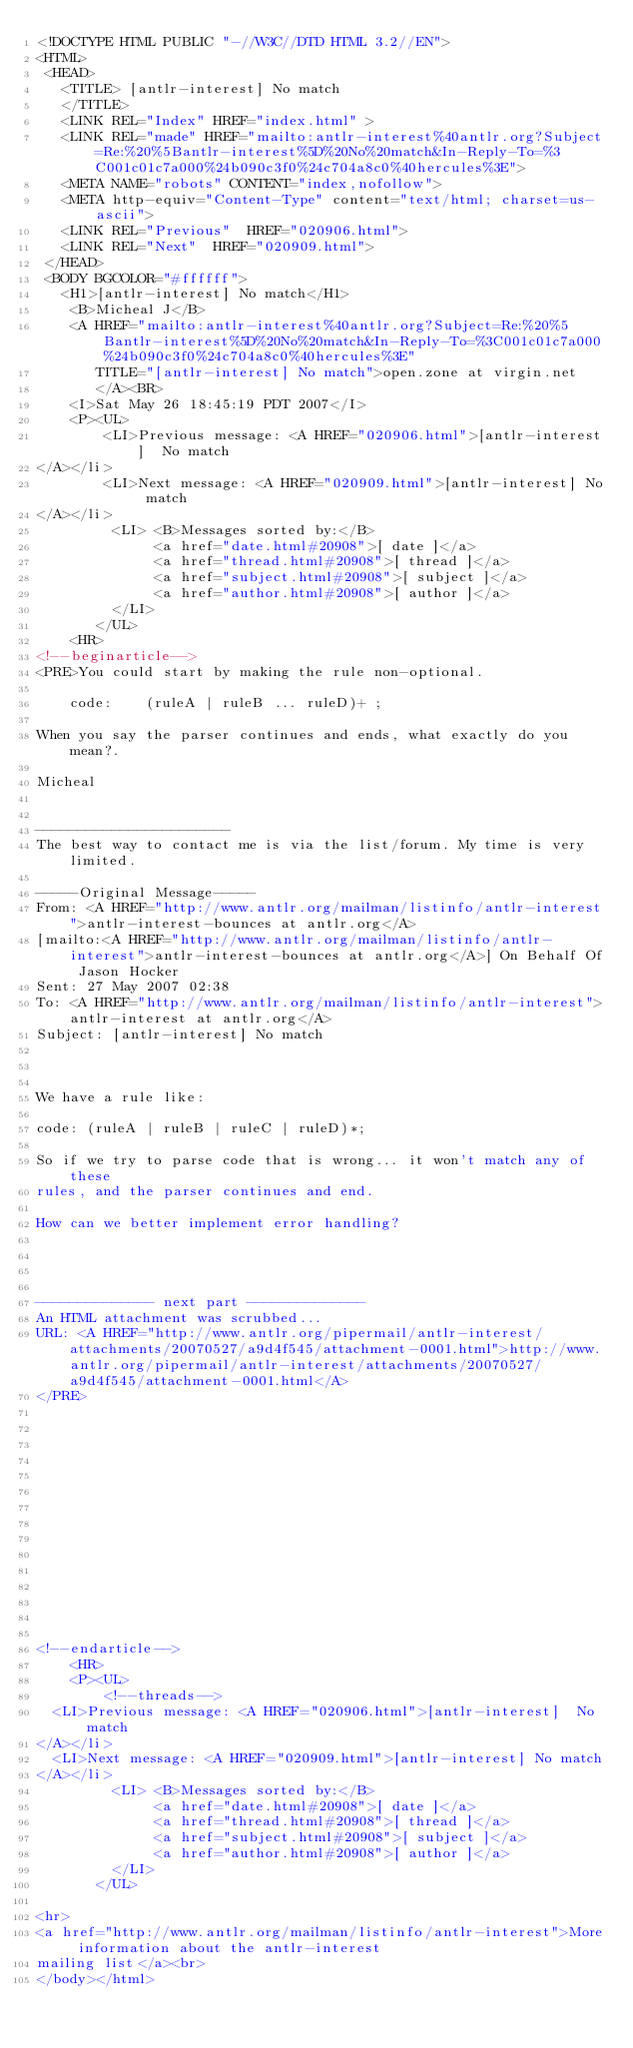Convert code to text. <code><loc_0><loc_0><loc_500><loc_500><_HTML_><!DOCTYPE HTML PUBLIC "-//W3C//DTD HTML 3.2//EN">
<HTML>
 <HEAD>
   <TITLE> [antlr-interest] No match
   </TITLE>
   <LINK REL="Index" HREF="index.html" >
   <LINK REL="made" HREF="mailto:antlr-interest%40antlr.org?Subject=Re:%20%5Bantlr-interest%5D%20No%20match&In-Reply-To=%3C001c01c7a000%24b090c3f0%24c704a8c0%40hercules%3E">
   <META NAME="robots" CONTENT="index,nofollow">
   <META http-equiv="Content-Type" content="text/html; charset=us-ascii">
   <LINK REL="Previous"  HREF="020906.html">
   <LINK REL="Next"  HREF="020909.html">
 </HEAD>
 <BODY BGCOLOR="#ffffff">
   <H1>[antlr-interest] No match</H1>
    <B>Micheal J</B> 
    <A HREF="mailto:antlr-interest%40antlr.org?Subject=Re:%20%5Bantlr-interest%5D%20No%20match&In-Reply-To=%3C001c01c7a000%24b090c3f0%24c704a8c0%40hercules%3E"
       TITLE="[antlr-interest] No match">open.zone at virgin.net
       </A><BR>
    <I>Sat May 26 18:45:19 PDT 2007</I>
    <P><UL>
        <LI>Previous message: <A HREF="020906.html">[antlr-interest]  No match
</A></li>
        <LI>Next message: <A HREF="020909.html">[antlr-interest] No match
</A></li>
         <LI> <B>Messages sorted by:</B> 
              <a href="date.html#20908">[ date ]</a>
              <a href="thread.html#20908">[ thread ]</a>
              <a href="subject.html#20908">[ subject ]</a>
              <a href="author.html#20908">[ author ]</a>
         </LI>
       </UL>
    <HR>  
<!--beginarticle-->
<PRE>You could start by making the rule non-optional.
 
    code:    (ruleA | ruleB ... ruleD)+ ;
 
When you say the parser continues and ends, what exactly do you mean?.
 
Micheal
 

-----------------------
The best way to contact me is via the list/forum. My time is very limited. 

-----Original Message-----
From: <A HREF="http://www.antlr.org/mailman/listinfo/antlr-interest">antlr-interest-bounces at antlr.org</A>
[mailto:<A HREF="http://www.antlr.org/mailman/listinfo/antlr-interest">antlr-interest-bounces at antlr.org</A>] On Behalf Of Jason Hocker
Sent: 27 May 2007 02:38
To: <A HREF="http://www.antlr.org/mailman/listinfo/antlr-interest">antlr-interest at antlr.org</A>
Subject: [antlr-interest] No match



We have a rule like: 

code: (ruleA | ruleB | ruleC | ruleD)*; 

So if we try to parse code that is wrong... it won't match any of these
rules, and the parser continues and end. 

How can we better implement error handling? 




-------------- next part --------------
An HTML attachment was scrubbed...
URL: <A HREF="http://www.antlr.org/pipermail/antlr-interest/attachments/20070527/a9d4f545/attachment-0001.html">http://www.antlr.org/pipermail/antlr-interest/attachments/20070527/a9d4f545/attachment-0001.html</A> 
</PRE>















<!--endarticle-->
    <HR>
    <P><UL>
        <!--threads-->
	<LI>Previous message: <A HREF="020906.html">[antlr-interest]  No match
</A></li>
	<LI>Next message: <A HREF="020909.html">[antlr-interest] No match
</A></li>
         <LI> <B>Messages sorted by:</B> 
              <a href="date.html#20908">[ date ]</a>
              <a href="thread.html#20908">[ thread ]</a>
              <a href="subject.html#20908">[ subject ]</a>
              <a href="author.html#20908">[ author ]</a>
         </LI>
       </UL>

<hr>
<a href="http://www.antlr.org/mailman/listinfo/antlr-interest">More information about the antlr-interest
mailing list</a><br>
</body></html>
</code> 